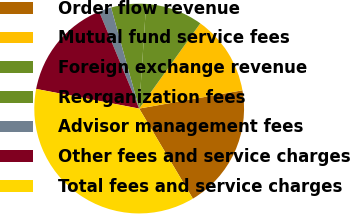Convert chart. <chart><loc_0><loc_0><loc_500><loc_500><pie_chart><fcel>Order flow revenue<fcel>Mutual fund service fees<fcel>Foreign exchange revenue<fcel>Reorganization fees<fcel>Advisor management fees<fcel>Other fees and service charges<fcel>Total fees and service charges<nl><fcel>19.23%<fcel>12.31%<fcel>8.84%<fcel>5.38%<fcel>1.91%<fcel>15.77%<fcel>36.55%<nl></chart> 